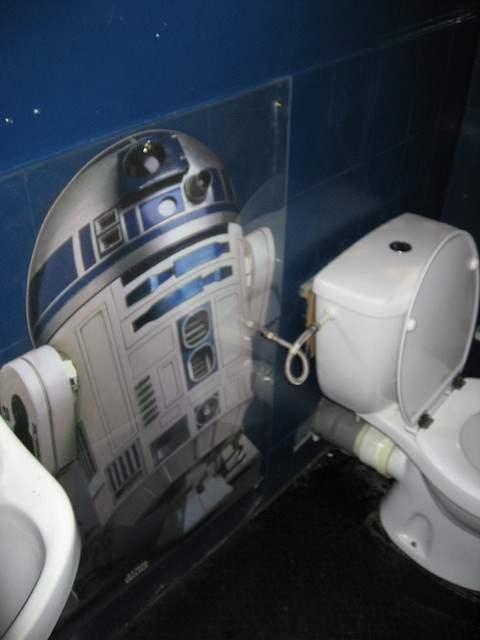Describe the objects in this image and their specific colors. I can see toilet in black, darkgray, lightgray, and gray tones and sink in black, lightgray, darkgray, and gray tones in this image. 